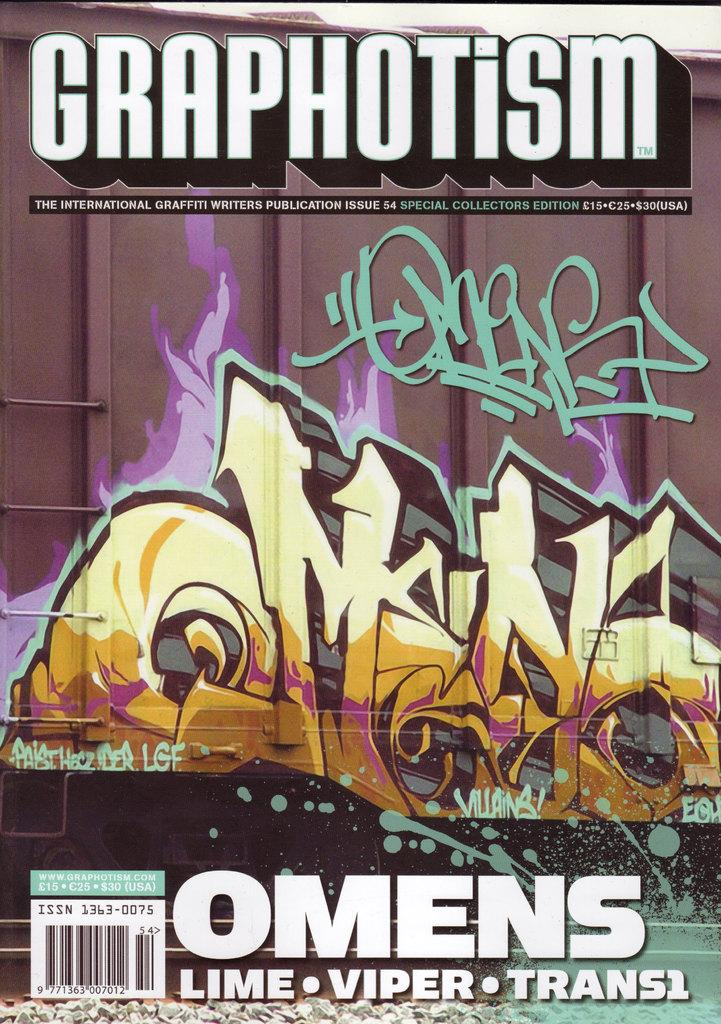What is featured on the poster in the image? The poster contains a painting and text. Can you describe the painting on the poster? Unfortunately, the specific details of the painting cannot be determined from the provided facts. What type of information is conveyed through the text on the poster? The content of the text on the poster cannot be determined from the provided facts. How many noses can be seen on the men standing on the hill in the image? There are no men or hills present in the image; it features a poster with a painting and text. 